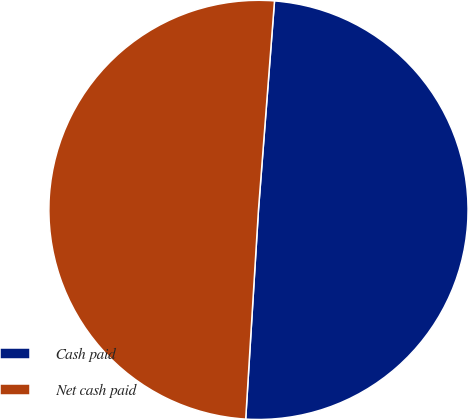Convert chart to OTSL. <chart><loc_0><loc_0><loc_500><loc_500><pie_chart><fcel>Cash paid<fcel>Net cash paid<nl><fcel>49.75%<fcel>50.25%<nl></chart> 